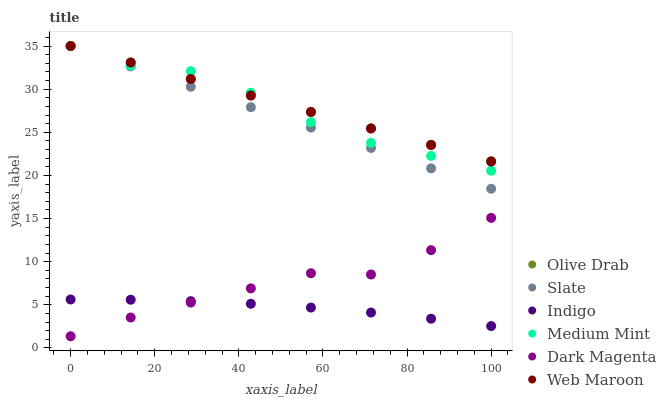Does Indigo have the minimum area under the curve?
Answer yes or no. Yes. Does Olive Drab have the maximum area under the curve?
Answer yes or no. Yes. Does Dark Magenta have the minimum area under the curve?
Answer yes or no. No. Does Dark Magenta have the maximum area under the curve?
Answer yes or no. No. Is Web Maroon the smoothest?
Answer yes or no. Yes. Is Medium Mint the roughest?
Answer yes or no. Yes. Is Indigo the smoothest?
Answer yes or no. No. Is Indigo the roughest?
Answer yes or no. No. Does Dark Magenta have the lowest value?
Answer yes or no. Yes. Does Indigo have the lowest value?
Answer yes or no. No. Does Olive Drab have the highest value?
Answer yes or no. Yes. Does Dark Magenta have the highest value?
Answer yes or no. No. Is Dark Magenta less than Medium Mint?
Answer yes or no. Yes. Is Web Maroon greater than Dark Magenta?
Answer yes or no. Yes. Does Dark Magenta intersect Indigo?
Answer yes or no. Yes. Is Dark Magenta less than Indigo?
Answer yes or no. No. Is Dark Magenta greater than Indigo?
Answer yes or no. No. Does Dark Magenta intersect Medium Mint?
Answer yes or no. No. 